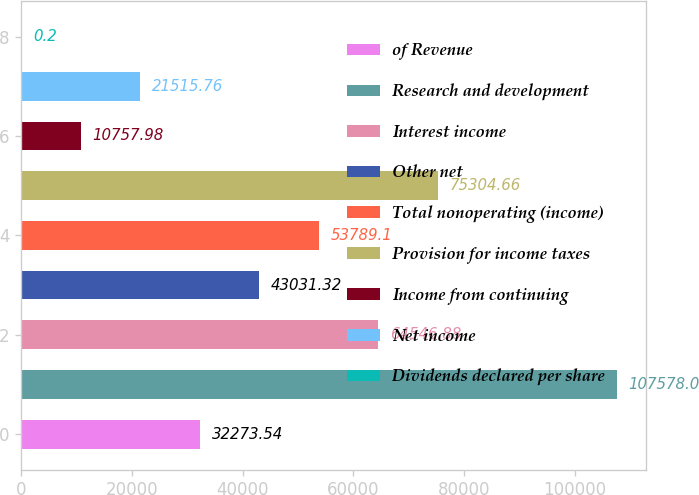<chart> <loc_0><loc_0><loc_500><loc_500><bar_chart><fcel>of Revenue<fcel>Research and development<fcel>Interest income<fcel>Other net<fcel>Total nonoperating (income)<fcel>Provision for income taxes<fcel>Income from continuing<fcel>Net income<fcel>Dividends declared per share<nl><fcel>32273.5<fcel>107578<fcel>64546.9<fcel>43031.3<fcel>53789.1<fcel>75304.7<fcel>10758<fcel>21515.8<fcel>0.2<nl></chart> 